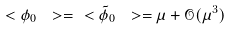Convert formula to latex. <formula><loc_0><loc_0><loc_500><loc_500>\ < \phi _ { 0 } \ > = \ < \tilde { \phi } _ { 0 } \ > = \mu + \mathcal { O } ( \mu ^ { 3 } )</formula> 